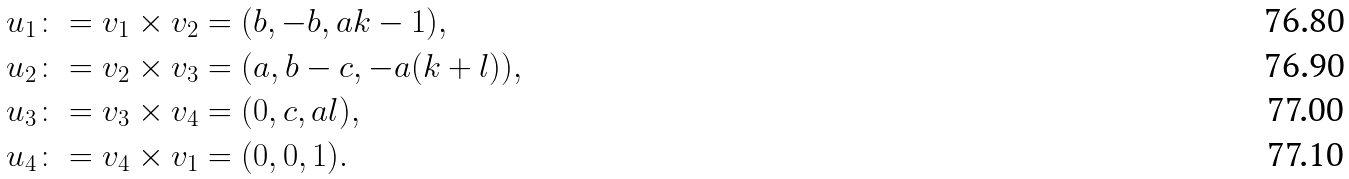Convert formula to latex. <formula><loc_0><loc_0><loc_500><loc_500>u _ { 1 } & \colon = v _ { 1 } \times v _ { 2 } = ( b , - b , a k - 1 ) , \\ u _ { 2 } & \colon = v _ { 2 } \times v _ { 3 } = ( a , b - c , - a ( k + l ) ) , \\ u _ { 3 } & \colon = v _ { 3 } \times v _ { 4 } = ( 0 , c , a l ) , \\ u _ { 4 } & \colon = v _ { 4 } \times v _ { 1 } = ( 0 , 0 , 1 ) .</formula> 